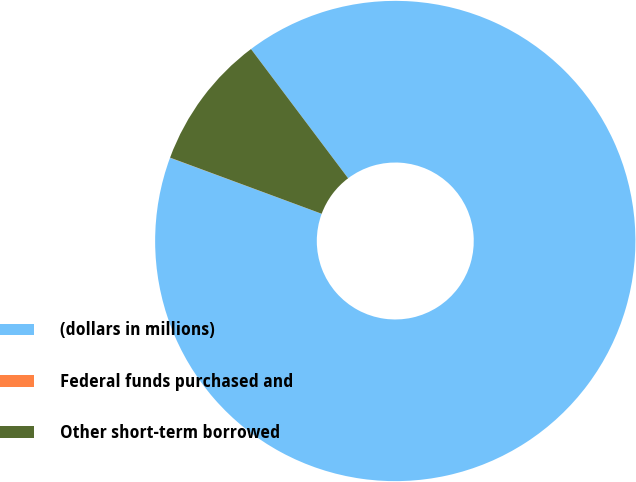Convert chart to OTSL. <chart><loc_0><loc_0><loc_500><loc_500><pie_chart><fcel>(dollars in millions)<fcel>Federal funds purchased and<fcel>Other short-term borrowed<nl><fcel>90.9%<fcel>0.01%<fcel>9.1%<nl></chart> 